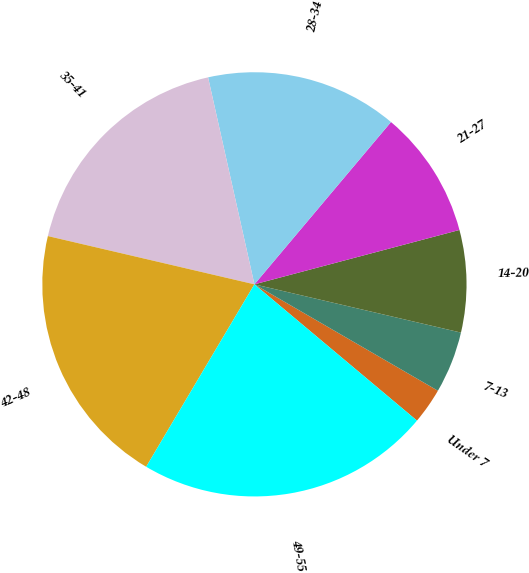Convert chart. <chart><loc_0><loc_0><loc_500><loc_500><pie_chart><fcel>Under 7<fcel>7-13<fcel>14-20<fcel>21-27<fcel>28-34<fcel>35-41<fcel>42-48<fcel>49-55<nl><fcel>2.74%<fcel>4.71%<fcel>7.78%<fcel>9.74%<fcel>14.64%<fcel>17.84%<fcel>20.13%<fcel>22.42%<nl></chart> 